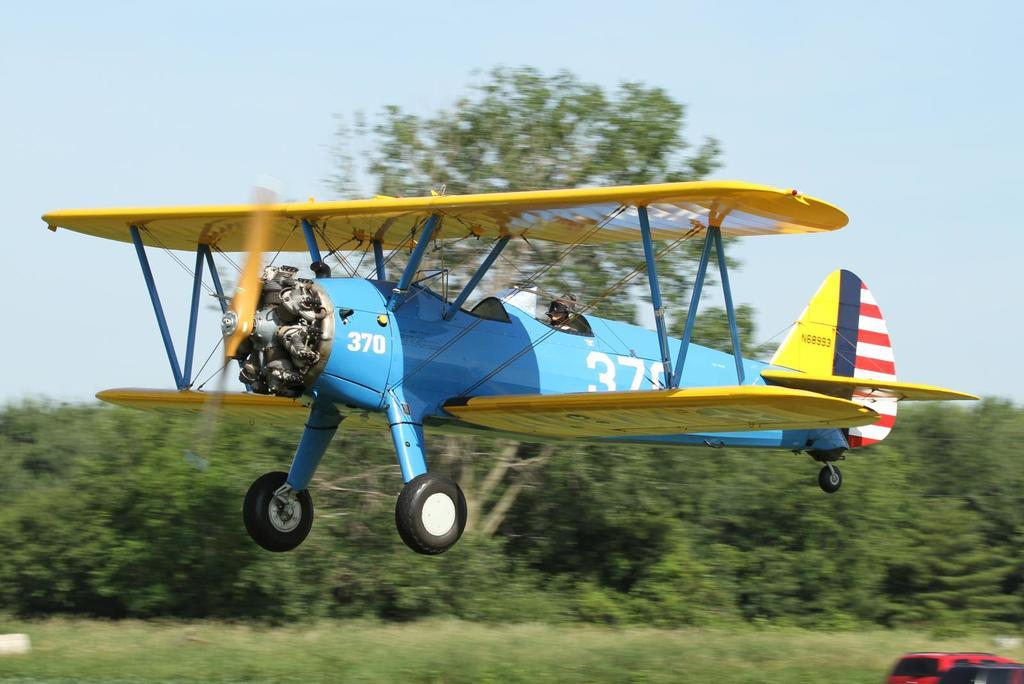<image>
Write a terse but informative summary of the picture. A blue and yellow airplane mid flight has the number 370 on the front and middle sections. 